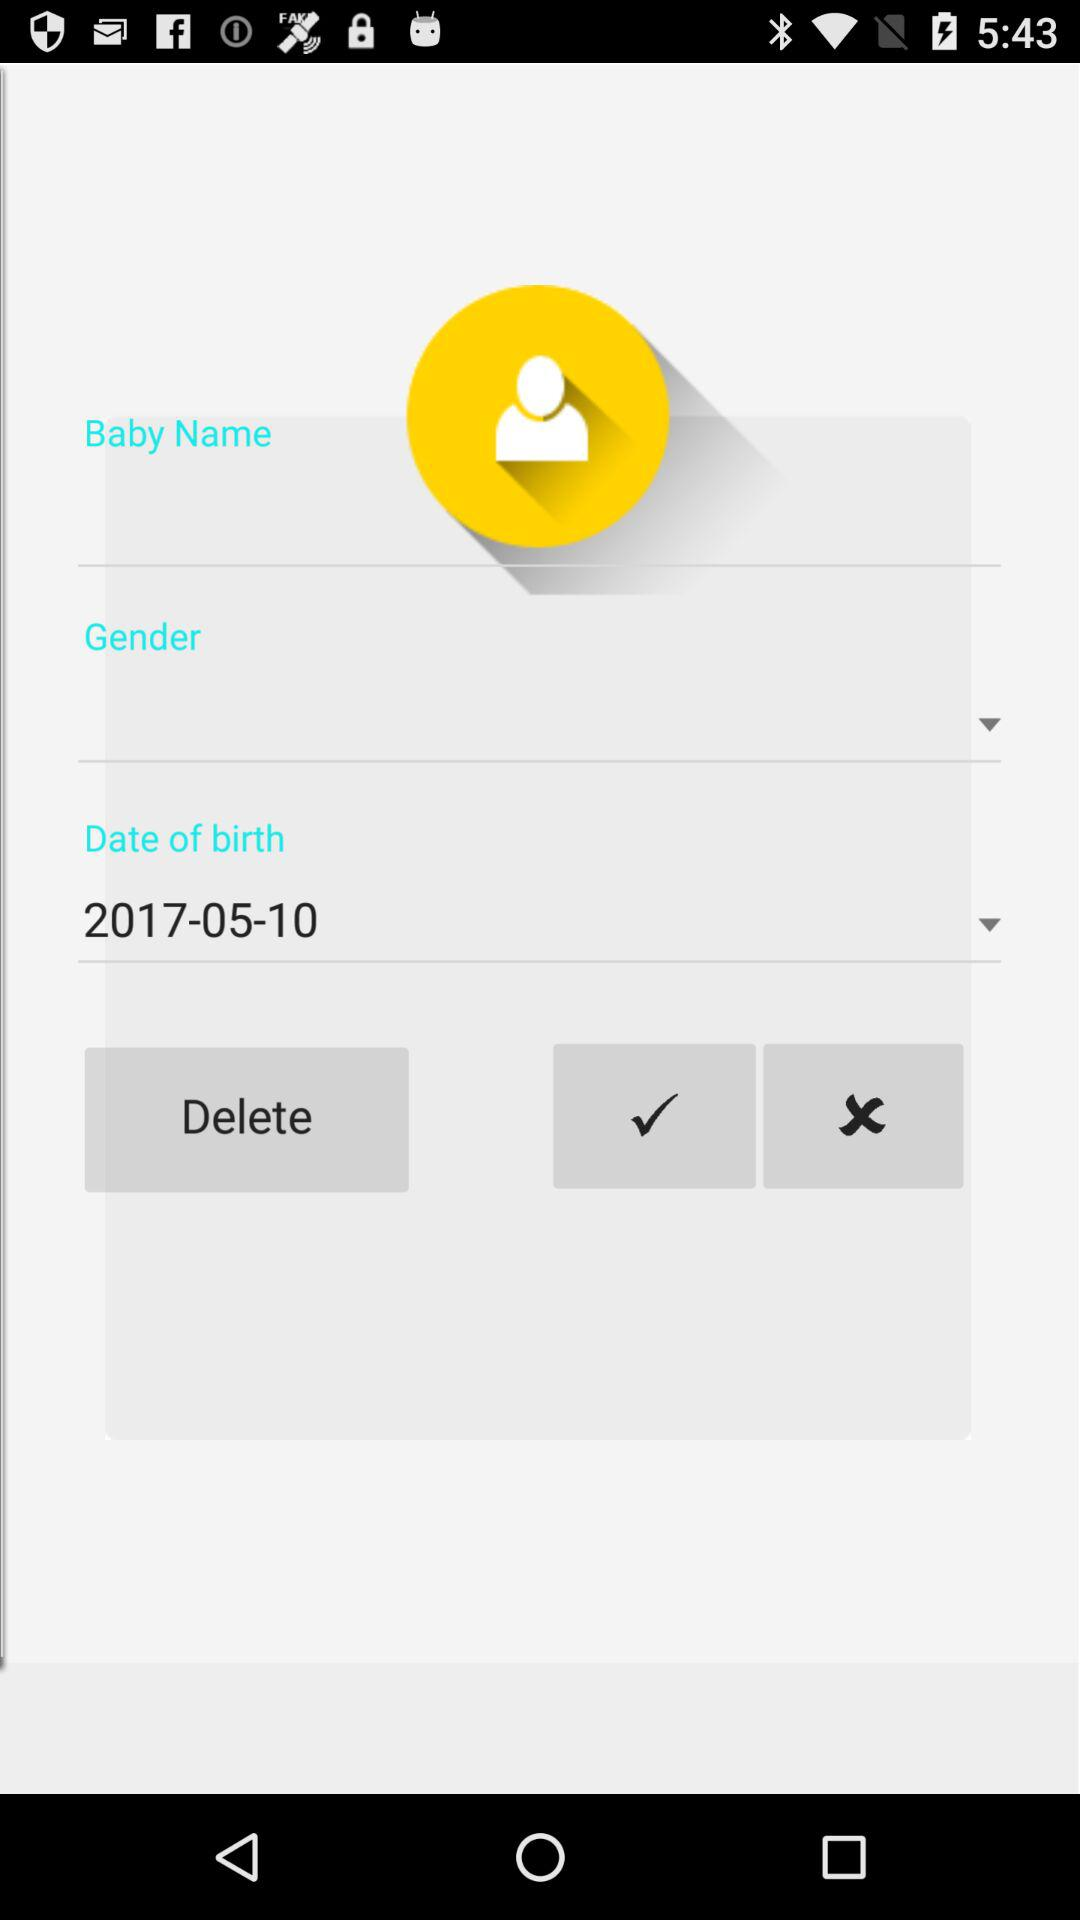What is the date of birth? The date of birth is October 5, 2017. 